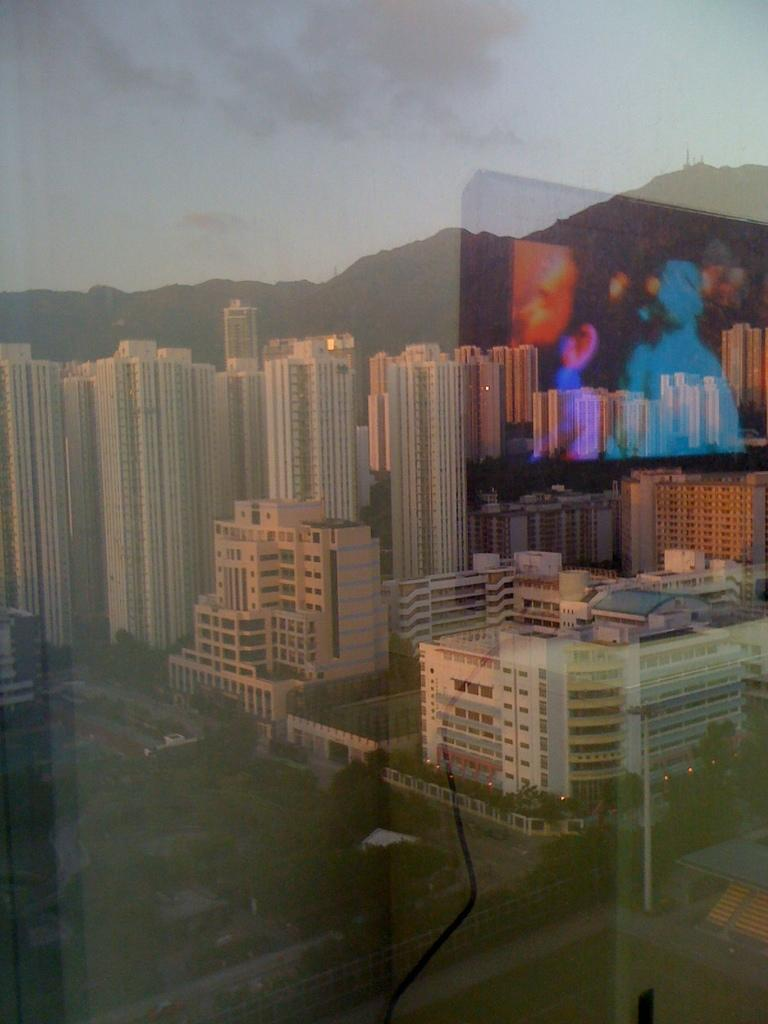What object is present in the image that has a view through it? There is a glass in the image. What types of scenery can be seen through the glass? Trees, buildings, mountains, and the sky are visible through the glass. Is there any reflection on the glass? Yes, there is a reflection of a monitor on the glass. What religious beliefs does the father in the image hold? There is no father or any reference to religion in the image. 